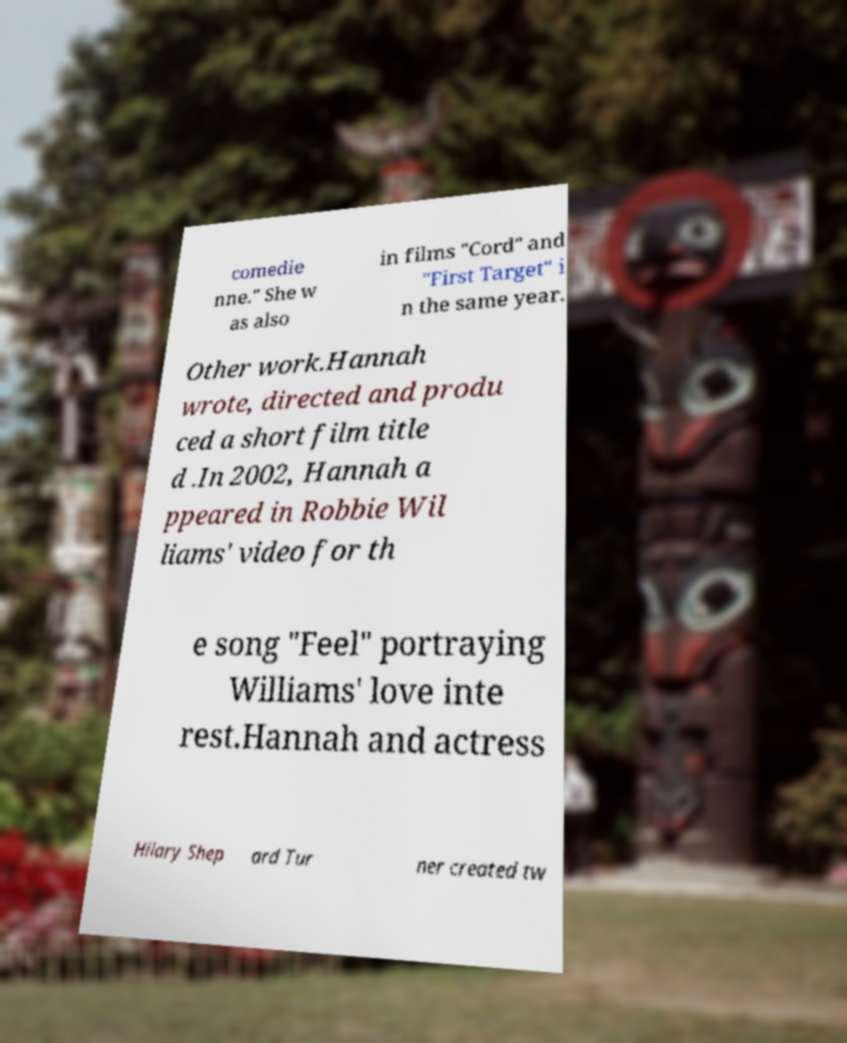Please read and relay the text visible in this image. What does it say? comedie nne." She w as also in films "Cord" and "First Target" i n the same year. Other work.Hannah wrote, directed and produ ced a short film title d .In 2002, Hannah a ppeared in Robbie Wil liams' video for th e song "Feel" portraying Williams' love inte rest.Hannah and actress Hilary Shep ard Tur ner created tw 